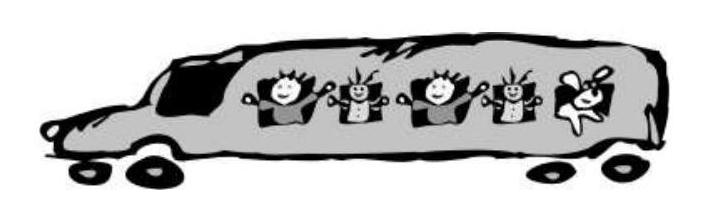What kind of transportation is depicted in the image? Describe its features. The image depicts a whimsical cartoon-style bus filled with joyful pupils. The bus is long and has windows along its side showcasing excited children with cheerful expressions. It has standard features like wheels and seems to be in motion, suggesting it is used for transporting kids, likely on a school trip or similar excursion.  What could be the possible destination of this bus and why? Given the joyful and excited expressions of the children, the bus could be heading towards a destination meant for leisure and education, such as a zoo, amusement park, or a cultural center. These destinations offer both fun and learning opportunities that would excite school children. 